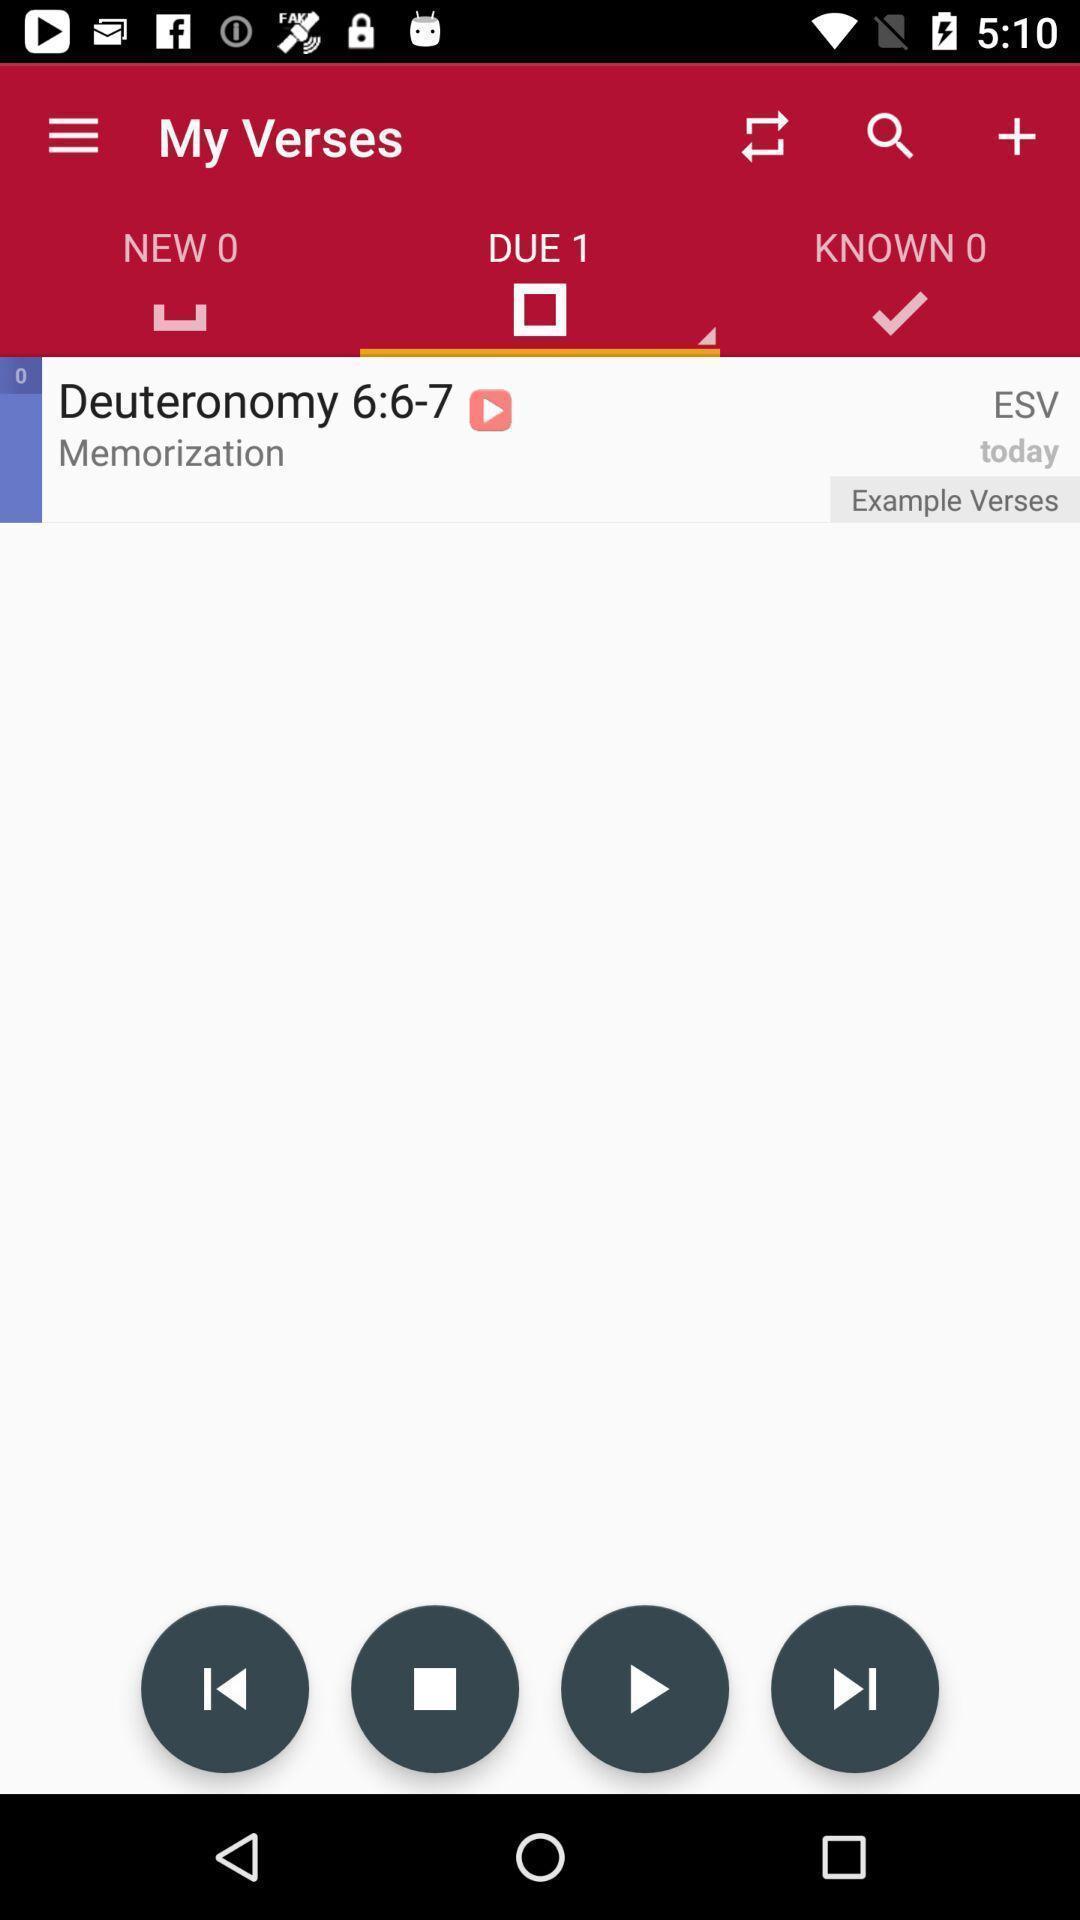Please provide a description for this image. Screen showing verses page with audio playing in bible app. 